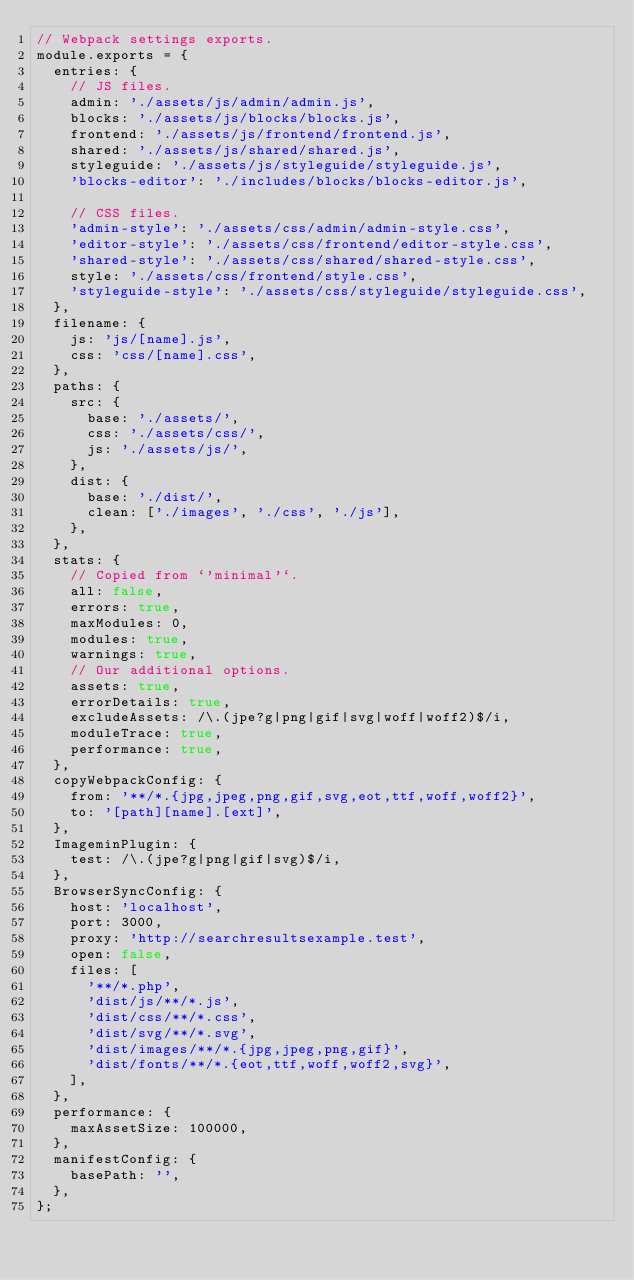Convert code to text. <code><loc_0><loc_0><loc_500><loc_500><_JavaScript_>// Webpack settings exports.
module.exports = {
	entries: {
		// JS files.
		admin: './assets/js/admin/admin.js',
		blocks: './assets/js/blocks/blocks.js',
		frontend: './assets/js/frontend/frontend.js',
		shared: './assets/js/shared/shared.js',
		styleguide: './assets/js/styleguide/styleguide.js',
		'blocks-editor': './includes/blocks/blocks-editor.js',

		// CSS files.
		'admin-style': './assets/css/admin/admin-style.css',
		'editor-style': './assets/css/frontend/editor-style.css',
		'shared-style': './assets/css/shared/shared-style.css',
		style: './assets/css/frontend/style.css',
		'styleguide-style': './assets/css/styleguide/styleguide.css',
	},
	filename: {
		js: 'js/[name].js',
		css: 'css/[name].css',
	},
	paths: {
		src: {
			base: './assets/',
			css: './assets/css/',
			js: './assets/js/',
		},
		dist: {
			base: './dist/',
			clean: ['./images', './css', './js'],
		},
	},
	stats: {
		// Copied from `'minimal'`.
		all: false,
		errors: true,
		maxModules: 0,
		modules: true,
		warnings: true,
		// Our additional options.
		assets: true,
		errorDetails: true,
		excludeAssets: /\.(jpe?g|png|gif|svg|woff|woff2)$/i,
		moduleTrace: true,
		performance: true,
	},
	copyWebpackConfig: {
		from: '**/*.{jpg,jpeg,png,gif,svg,eot,ttf,woff,woff2}',
		to: '[path][name].[ext]',
	},
	ImageminPlugin: {
		test: /\.(jpe?g|png|gif|svg)$/i,
	},
	BrowserSyncConfig: {
		host: 'localhost',
		port: 3000,
		proxy: 'http://searchresultsexample.test',
		open: false,
		files: [
			'**/*.php',
			'dist/js/**/*.js',
			'dist/css/**/*.css',
			'dist/svg/**/*.svg',
			'dist/images/**/*.{jpg,jpeg,png,gif}',
			'dist/fonts/**/*.{eot,ttf,woff,woff2,svg}',
		],
	},
	performance: {
		maxAssetSize: 100000,
	},
	manifestConfig: {
		basePath: '',
	},
};
</code> 